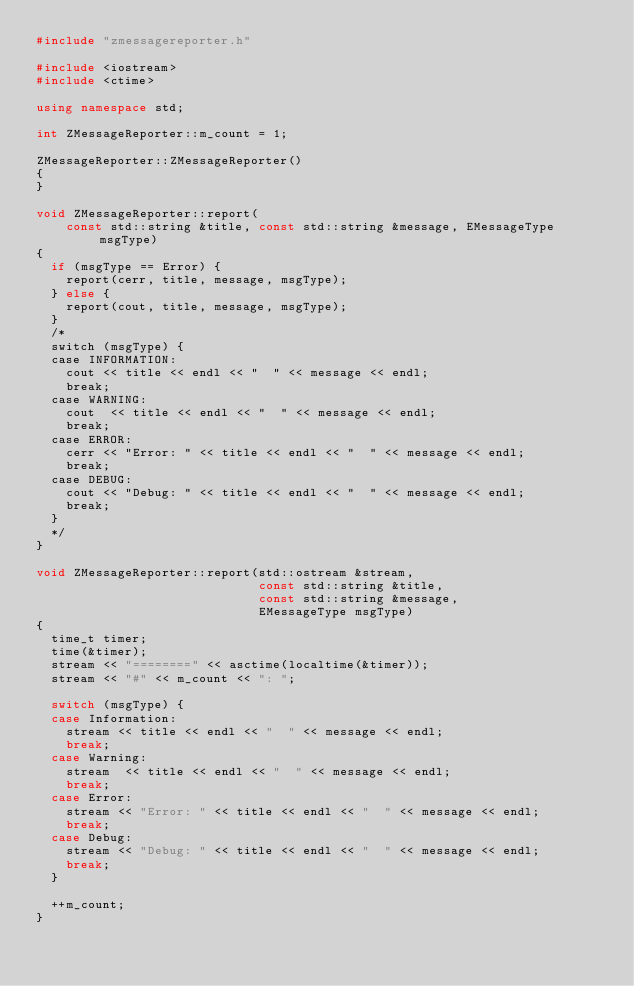<code> <loc_0><loc_0><loc_500><loc_500><_C++_>#include "zmessagereporter.h"

#include <iostream>
#include <ctime>

using namespace std;

int ZMessageReporter::m_count = 1;

ZMessageReporter::ZMessageReporter()
{
}

void ZMessageReporter::report(
    const std::string &title, const std::string &message, EMessageType msgType)
{
  if (msgType == Error) {
    report(cerr, title, message, msgType);
  } else {
    report(cout, title, message, msgType);
  }
  /*
  switch (msgType) {
  case INFORMATION:
    cout << title << endl << "  " << message << endl;
    break;
  case WARNING:
    cout  << title << endl << "  " << message << endl;
    break;
  case ERROR:
    cerr << "Error: " << title << endl << "  " << message << endl;
    break;
  case DEBUG:
    cout << "Debug: " << title << endl << "  " << message << endl;
    break;
  }
  */
}

void ZMessageReporter::report(std::ostream &stream,
                              const std::string &title,
                              const std::string &message,
                              EMessageType msgType)
{
  time_t timer;
  time(&timer);
  stream << "========" << asctime(localtime(&timer));
  stream << "#" << m_count << ": ";

  switch (msgType) {
  case Information:
    stream << title << endl << "  " << message << endl;
    break;
  case Warning:
    stream  << title << endl << "  " << message << endl;
    break;
  case Error:
    stream << "Error: " << title << endl << "  " << message << endl;
    break;
  case Debug:
    stream << "Debug: " << title << endl << "  " << message << endl;
    break;
  }

  ++m_count;
}
</code> 